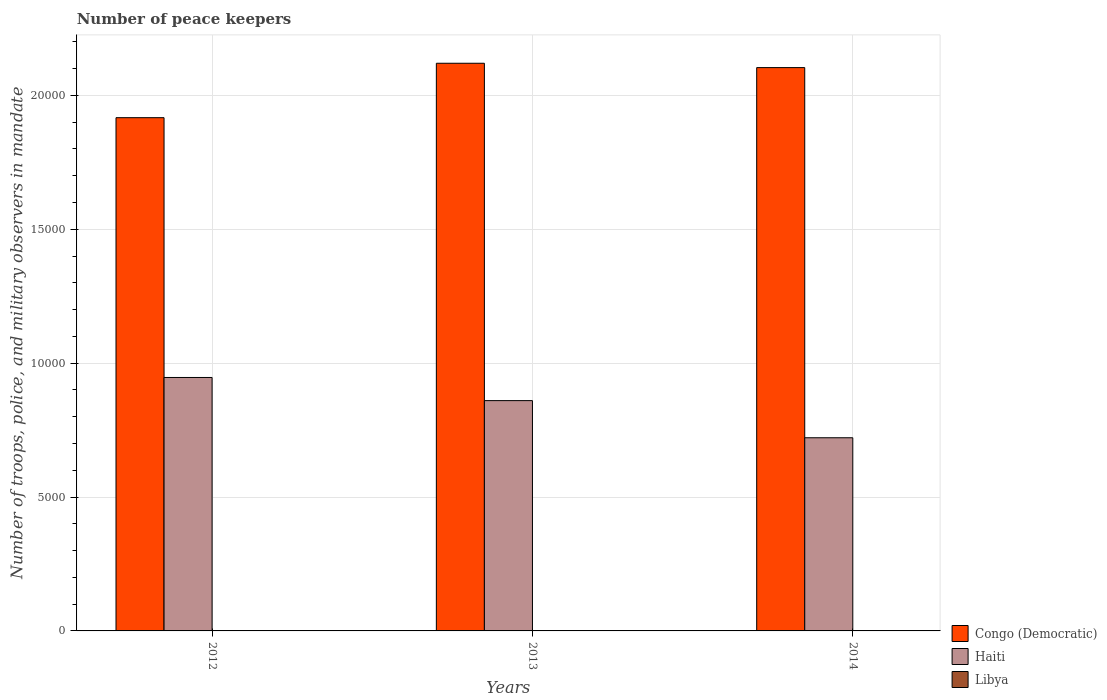How many different coloured bars are there?
Your answer should be very brief. 3. How many groups of bars are there?
Ensure brevity in your answer.  3. Are the number of bars per tick equal to the number of legend labels?
Give a very brief answer. Yes. How many bars are there on the 2nd tick from the left?
Your response must be concise. 3. How many bars are there on the 1st tick from the right?
Offer a terse response. 3. What is the number of peace keepers in in Haiti in 2013?
Your response must be concise. 8600. Across all years, what is the maximum number of peace keepers in in Haiti?
Provide a short and direct response. 9464. Across all years, what is the minimum number of peace keepers in in Congo (Democratic)?
Make the answer very short. 1.92e+04. What is the difference between the number of peace keepers in in Haiti in 2014 and the number of peace keepers in in Congo (Democratic) in 2012?
Give a very brief answer. -1.20e+04. In the year 2014, what is the difference between the number of peace keepers in in Libya and number of peace keepers in in Haiti?
Your response must be concise. -7211. In how many years, is the number of peace keepers in in Haiti greater than 10000?
Your answer should be very brief. 0. Is the number of peace keepers in in Haiti in 2012 less than that in 2014?
Your response must be concise. No. What is the difference between the highest and the second highest number of peace keepers in in Haiti?
Your answer should be compact. 864. What is the difference between the highest and the lowest number of peace keepers in in Congo (Democratic)?
Provide a short and direct response. 2032. In how many years, is the number of peace keepers in in Libya greater than the average number of peace keepers in in Libya taken over all years?
Your response must be concise. 1. Is the sum of the number of peace keepers in in Congo (Democratic) in 2012 and 2013 greater than the maximum number of peace keepers in in Haiti across all years?
Your response must be concise. Yes. What does the 2nd bar from the left in 2013 represents?
Your answer should be very brief. Haiti. What does the 2nd bar from the right in 2014 represents?
Your answer should be very brief. Haiti. How many bars are there?
Keep it short and to the point. 9. Are the values on the major ticks of Y-axis written in scientific E-notation?
Keep it short and to the point. No. Where does the legend appear in the graph?
Give a very brief answer. Bottom right. What is the title of the graph?
Offer a very short reply. Number of peace keepers. What is the label or title of the Y-axis?
Provide a short and direct response. Number of troops, police, and military observers in mandate. What is the Number of troops, police, and military observers in mandate in Congo (Democratic) in 2012?
Keep it short and to the point. 1.92e+04. What is the Number of troops, police, and military observers in mandate of Haiti in 2012?
Offer a very short reply. 9464. What is the Number of troops, police, and military observers in mandate of Congo (Democratic) in 2013?
Ensure brevity in your answer.  2.12e+04. What is the Number of troops, police, and military observers in mandate of Haiti in 2013?
Provide a short and direct response. 8600. What is the Number of troops, police, and military observers in mandate in Libya in 2013?
Give a very brief answer. 11. What is the Number of troops, police, and military observers in mandate of Congo (Democratic) in 2014?
Offer a terse response. 2.10e+04. What is the Number of troops, police, and military observers in mandate in Haiti in 2014?
Your answer should be very brief. 7213. Across all years, what is the maximum Number of troops, police, and military observers in mandate in Congo (Democratic)?
Keep it short and to the point. 2.12e+04. Across all years, what is the maximum Number of troops, police, and military observers in mandate in Haiti?
Your answer should be compact. 9464. Across all years, what is the minimum Number of troops, police, and military observers in mandate in Congo (Democratic)?
Keep it short and to the point. 1.92e+04. Across all years, what is the minimum Number of troops, police, and military observers in mandate of Haiti?
Offer a very short reply. 7213. Across all years, what is the minimum Number of troops, police, and military observers in mandate of Libya?
Ensure brevity in your answer.  2. What is the total Number of troops, police, and military observers in mandate in Congo (Democratic) in the graph?
Provide a short and direct response. 6.14e+04. What is the total Number of troops, police, and military observers in mandate of Haiti in the graph?
Ensure brevity in your answer.  2.53e+04. What is the difference between the Number of troops, police, and military observers in mandate of Congo (Democratic) in 2012 and that in 2013?
Provide a short and direct response. -2032. What is the difference between the Number of troops, police, and military observers in mandate in Haiti in 2012 and that in 2013?
Provide a short and direct response. 864. What is the difference between the Number of troops, police, and military observers in mandate of Congo (Democratic) in 2012 and that in 2014?
Provide a succinct answer. -1870. What is the difference between the Number of troops, police, and military observers in mandate of Haiti in 2012 and that in 2014?
Provide a short and direct response. 2251. What is the difference between the Number of troops, police, and military observers in mandate of Libya in 2012 and that in 2014?
Offer a terse response. 0. What is the difference between the Number of troops, police, and military observers in mandate of Congo (Democratic) in 2013 and that in 2014?
Offer a very short reply. 162. What is the difference between the Number of troops, police, and military observers in mandate in Haiti in 2013 and that in 2014?
Give a very brief answer. 1387. What is the difference between the Number of troops, police, and military observers in mandate of Congo (Democratic) in 2012 and the Number of troops, police, and military observers in mandate of Haiti in 2013?
Make the answer very short. 1.06e+04. What is the difference between the Number of troops, police, and military observers in mandate in Congo (Democratic) in 2012 and the Number of troops, police, and military observers in mandate in Libya in 2013?
Your answer should be compact. 1.92e+04. What is the difference between the Number of troops, police, and military observers in mandate in Haiti in 2012 and the Number of troops, police, and military observers in mandate in Libya in 2013?
Offer a terse response. 9453. What is the difference between the Number of troops, police, and military observers in mandate of Congo (Democratic) in 2012 and the Number of troops, police, and military observers in mandate of Haiti in 2014?
Offer a very short reply. 1.20e+04. What is the difference between the Number of troops, police, and military observers in mandate of Congo (Democratic) in 2012 and the Number of troops, police, and military observers in mandate of Libya in 2014?
Provide a succinct answer. 1.92e+04. What is the difference between the Number of troops, police, and military observers in mandate in Haiti in 2012 and the Number of troops, police, and military observers in mandate in Libya in 2014?
Ensure brevity in your answer.  9462. What is the difference between the Number of troops, police, and military observers in mandate in Congo (Democratic) in 2013 and the Number of troops, police, and military observers in mandate in Haiti in 2014?
Provide a short and direct response. 1.40e+04. What is the difference between the Number of troops, police, and military observers in mandate of Congo (Democratic) in 2013 and the Number of troops, police, and military observers in mandate of Libya in 2014?
Give a very brief answer. 2.12e+04. What is the difference between the Number of troops, police, and military observers in mandate of Haiti in 2013 and the Number of troops, police, and military observers in mandate of Libya in 2014?
Your response must be concise. 8598. What is the average Number of troops, police, and military observers in mandate in Congo (Democratic) per year?
Provide a succinct answer. 2.05e+04. What is the average Number of troops, police, and military observers in mandate of Haiti per year?
Offer a terse response. 8425.67. In the year 2012, what is the difference between the Number of troops, police, and military observers in mandate of Congo (Democratic) and Number of troops, police, and military observers in mandate of Haiti?
Keep it short and to the point. 9702. In the year 2012, what is the difference between the Number of troops, police, and military observers in mandate of Congo (Democratic) and Number of troops, police, and military observers in mandate of Libya?
Your answer should be very brief. 1.92e+04. In the year 2012, what is the difference between the Number of troops, police, and military observers in mandate in Haiti and Number of troops, police, and military observers in mandate in Libya?
Keep it short and to the point. 9462. In the year 2013, what is the difference between the Number of troops, police, and military observers in mandate of Congo (Democratic) and Number of troops, police, and military observers in mandate of Haiti?
Provide a succinct answer. 1.26e+04. In the year 2013, what is the difference between the Number of troops, police, and military observers in mandate in Congo (Democratic) and Number of troops, police, and military observers in mandate in Libya?
Offer a very short reply. 2.12e+04. In the year 2013, what is the difference between the Number of troops, police, and military observers in mandate in Haiti and Number of troops, police, and military observers in mandate in Libya?
Ensure brevity in your answer.  8589. In the year 2014, what is the difference between the Number of troops, police, and military observers in mandate of Congo (Democratic) and Number of troops, police, and military observers in mandate of Haiti?
Your answer should be compact. 1.38e+04. In the year 2014, what is the difference between the Number of troops, police, and military observers in mandate in Congo (Democratic) and Number of troops, police, and military observers in mandate in Libya?
Your response must be concise. 2.10e+04. In the year 2014, what is the difference between the Number of troops, police, and military observers in mandate of Haiti and Number of troops, police, and military observers in mandate of Libya?
Offer a terse response. 7211. What is the ratio of the Number of troops, police, and military observers in mandate in Congo (Democratic) in 2012 to that in 2013?
Offer a terse response. 0.9. What is the ratio of the Number of troops, police, and military observers in mandate of Haiti in 2012 to that in 2013?
Provide a short and direct response. 1.1. What is the ratio of the Number of troops, police, and military observers in mandate of Libya in 2012 to that in 2013?
Offer a very short reply. 0.18. What is the ratio of the Number of troops, police, and military observers in mandate of Congo (Democratic) in 2012 to that in 2014?
Ensure brevity in your answer.  0.91. What is the ratio of the Number of troops, police, and military observers in mandate in Haiti in 2012 to that in 2014?
Your answer should be compact. 1.31. What is the ratio of the Number of troops, police, and military observers in mandate in Libya in 2012 to that in 2014?
Your answer should be very brief. 1. What is the ratio of the Number of troops, police, and military observers in mandate in Congo (Democratic) in 2013 to that in 2014?
Ensure brevity in your answer.  1.01. What is the ratio of the Number of troops, police, and military observers in mandate of Haiti in 2013 to that in 2014?
Make the answer very short. 1.19. What is the difference between the highest and the second highest Number of troops, police, and military observers in mandate of Congo (Democratic)?
Provide a short and direct response. 162. What is the difference between the highest and the second highest Number of troops, police, and military observers in mandate of Haiti?
Your answer should be compact. 864. What is the difference between the highest and the lowest Number of troops, police, and military observers in mandate in Congo (Democratic)?
Your response must be concise. 2032. What is the difference between the highest and the lowest Number of troops, police, and military observers in mandate in Haiti?
Your answer should be very brief. 2251. 